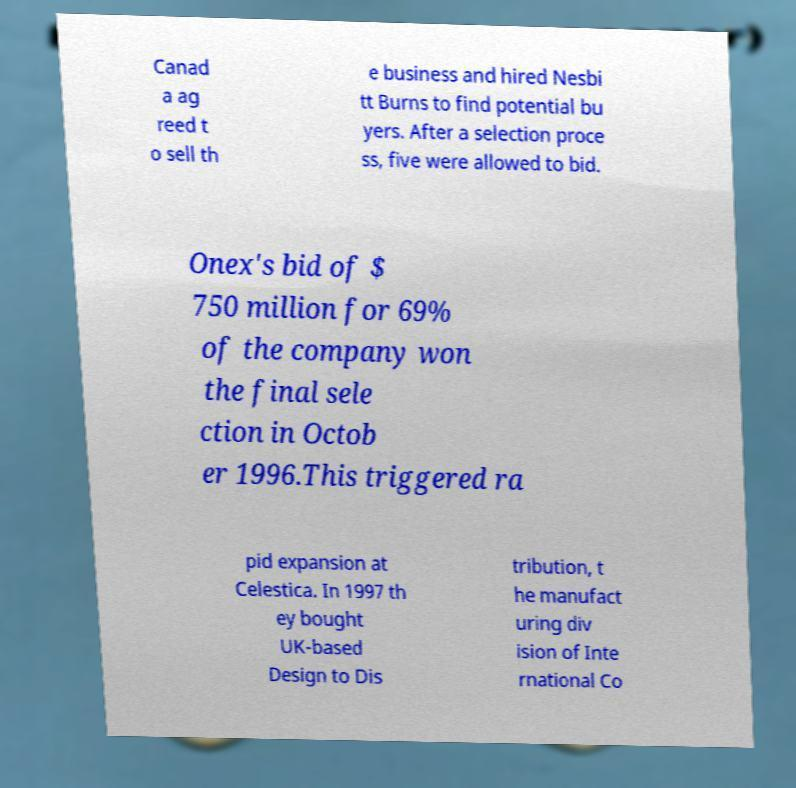I need the written content from this picture converted into text. Can you do that? Canad a ag reed t o sell th e business and hired Nesbi tt Burns to find potential bu yers. After a selection proce ss, five were allowed to bid. Onex's bid of $ 750 million for 69% of the company won the final sele ction in Octob er 1996.This triggered ra pid expansion at Celestica. In 1997 th ey bought UK-based Design to Dis tribution, t he manufact uring div ision of Inte rnational Co 